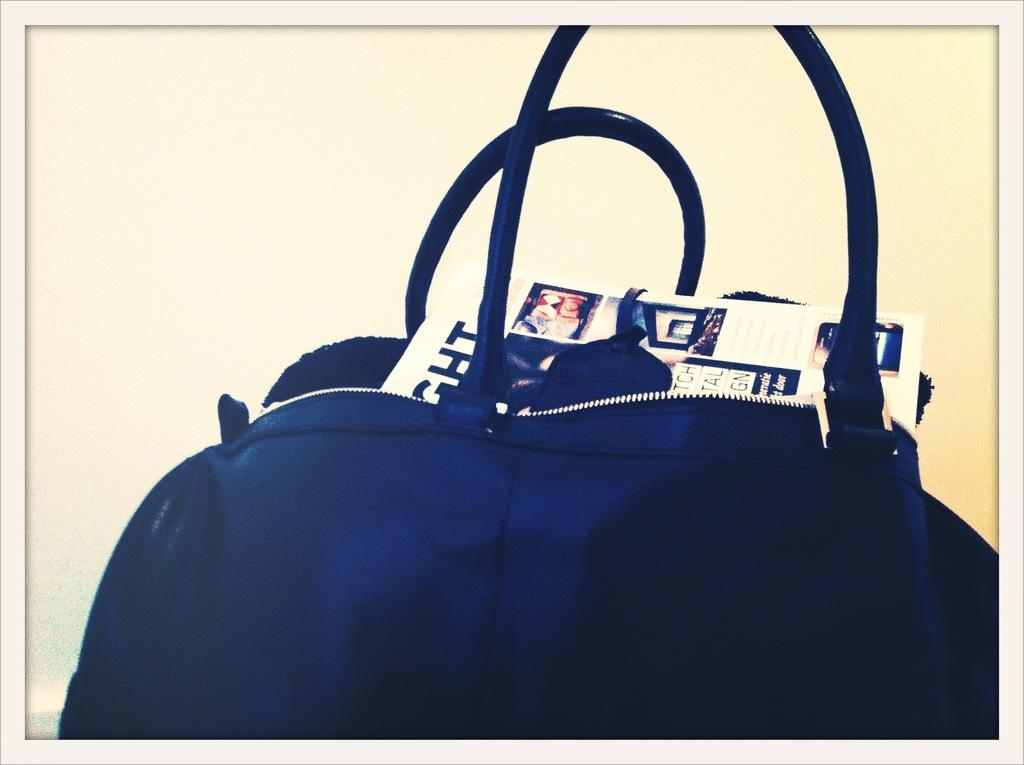What type of handbag is visible in the image? There is a blue color leather handbag in the image. What is inside the handbag? There are newspapers inside the handbag. What can be seen in the background of the image? There is a wall in the background of the image. How many fish are swimming in the handbag in the image? There are no fish present in the image; it features a blue color leather handbag with newspapers inside. 